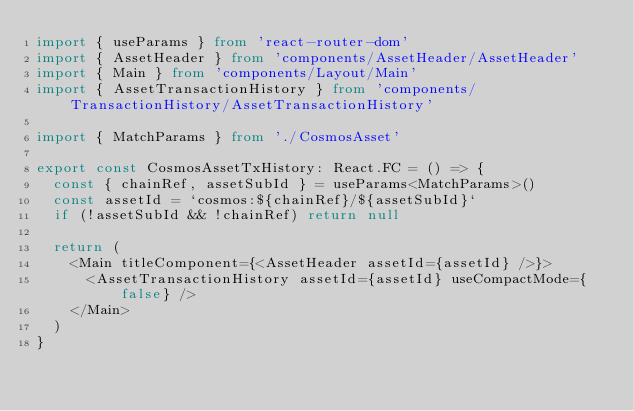Convert code to text. <code><loc_0><loc_0><loc_500><loc_500><_TypeScript_>import { useParams } from 'react-router-dom'
import { AssetHeader } from 'components/AssetHeader/AssetHeader'
import { Main } from 'components/Layout/Main'
import { AssetTransactionHistory } from 'components/TransactionHistory/AssetTransactionHistory'

import { MatchParams } from './CosmosAsset'

export const CosmosAssetTxHistory: React.FC = () => {
  const { chainRef, assetSubId } = useParams<MatchParams>()
  const assetId = `cosmos:${chainRef}/${assetSubId}`
  if (!assetSubId && !chainRef) return null

  return (
    <Main titleComponent={<AssetHeader assetId={assetId} />}>
      <AssetTransactionHistory assetId={assetId} useCompactMode={false} />
    </Main>
  )
}
</code> 